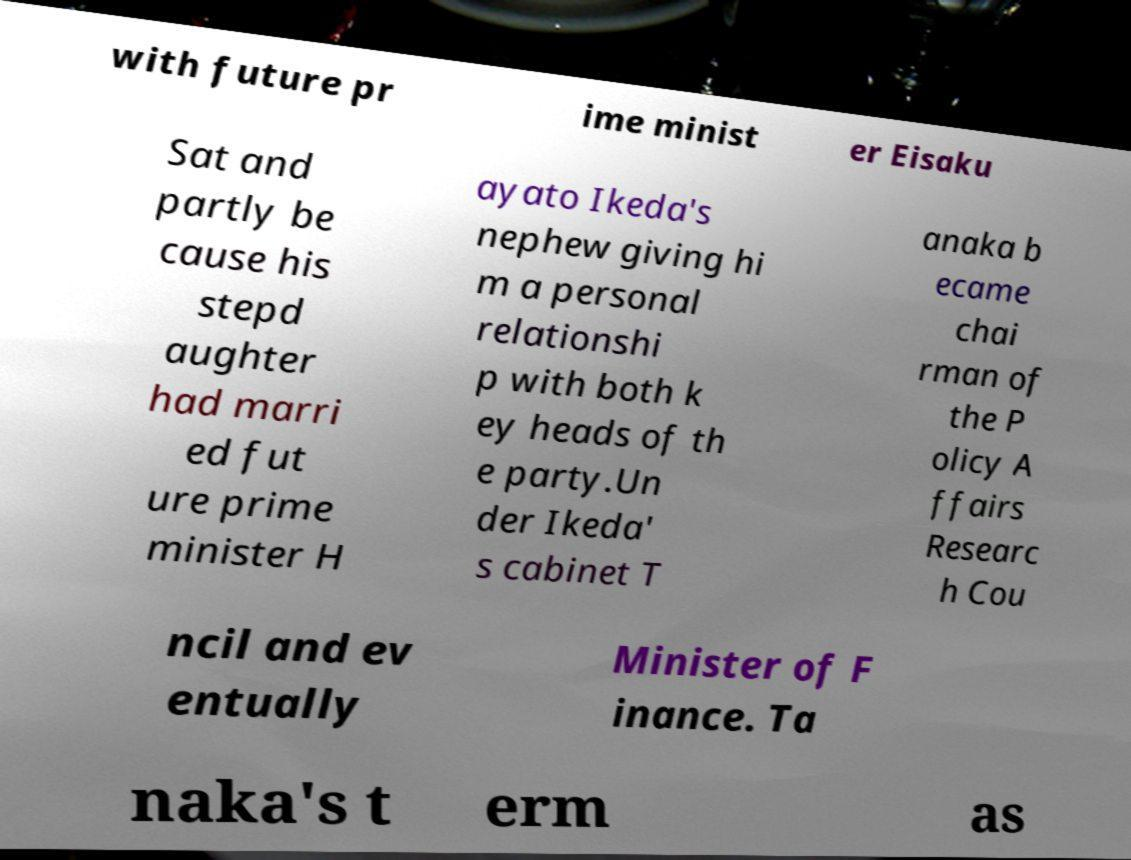Please read and relay the text visible in this image. What does it say? with future pr ime minist er Eisaku Sat and partly be cause his stepd aughter had marri ed fut ure prime minister H ayato Ikeda's nephew giving hi m a personal relationshi p with both k ey heads of th e party.Un der Ikeda' s cabinet T anaka b ecame chai rman of the P olicy A ffairs Researc h Cou ncil and ev entually Minister of F inance. Ta naka's t erm as 